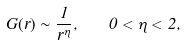<formula> <loc_0><loc_0><loc_500><loc_500>G ( r ) \sim \frac { 1 } { r ^ { \eta } } , \quad 0 < \eta < 2 ,</formula> 